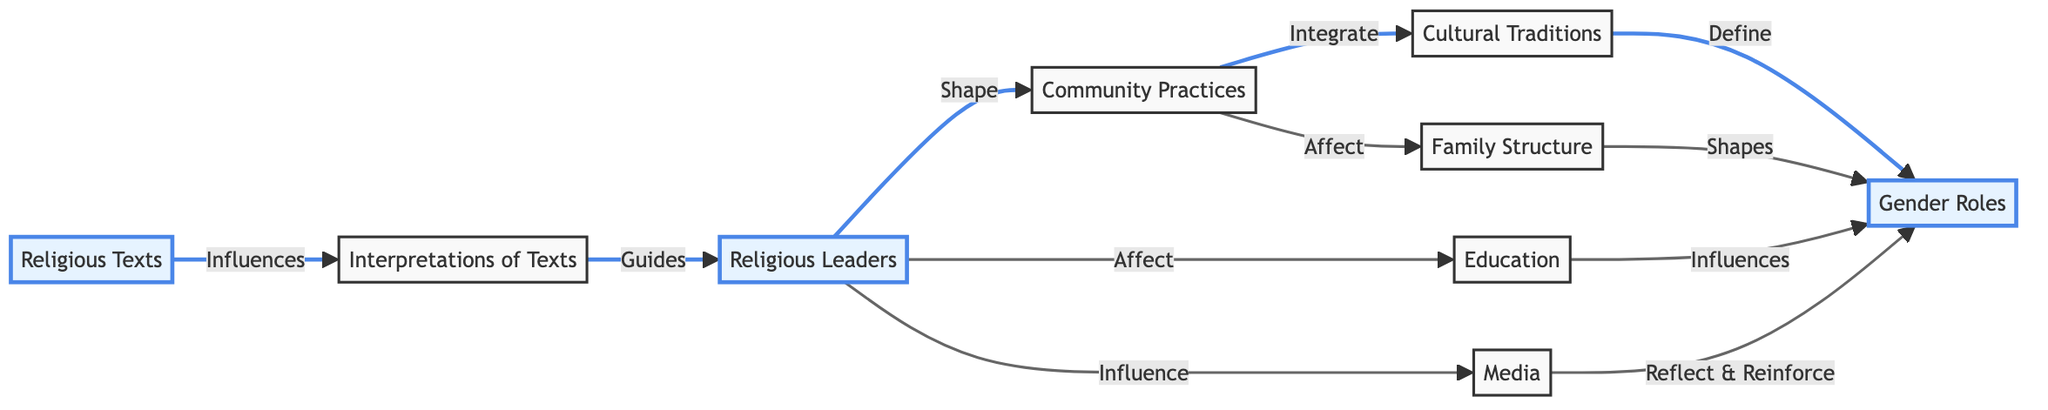What are the total number of nodes in the diagram? The diagram lists eight distinct entities connected by edges. These entities are Religious Texts, Interpretations of Texts, Religious Leaders, Community Practices, Cultural Traditions, Gender Roles, Education, Media, and Family Structure. Counting these gives a total of eight nodes.
Answer: 8 Which node directly influences Gender Roles through Cultural Traditions? The direction of influence flows from Cultural Traditions to Gender Roles, as indicated by the edge labeled "Define". Therefore, the node that directly influences Gender Roles through Cultural Traditions is Cultural Traditions itself.
Answer: Cultural Traditions What is the relationship between Community Practices and Family Structure? The edge traced from Community Practices to Family Structure is labeled "Affect", meaning that Community Practices have an effect on Family Structure in the context of this graph.
Answer: Affect Which nodes do Religious Leaders influence? According to the diagram, Religious Leaders influence three nodes: Education, Media, and Community Practices. Therefore, the nodes influenced by Religious Leaders include Education and Media, as well as affecting Community Practices.
Answer: Education, Media, Community Practices What is the flow of influence from Religious Texts to Gender Roles? The flow begins at Religious Texts, which influences Interpretations of Texts. Next, Interpretations guide Religious Leaders, who then shape Community Practices. From there, Community Practices integrate into Cultural Traditions, which finally define Gender Roles. Thus, the flow of influence is from Religious Texts to Interpretations of Texts, then to Religious Leaders, followed by Community Practices, Cultural Traditions, and lastly to Gender Roles.
Answer: Religious Texts to Gender Roles through Interpretations, Religious Leaders, Community Practices, and Cultural Traditions 